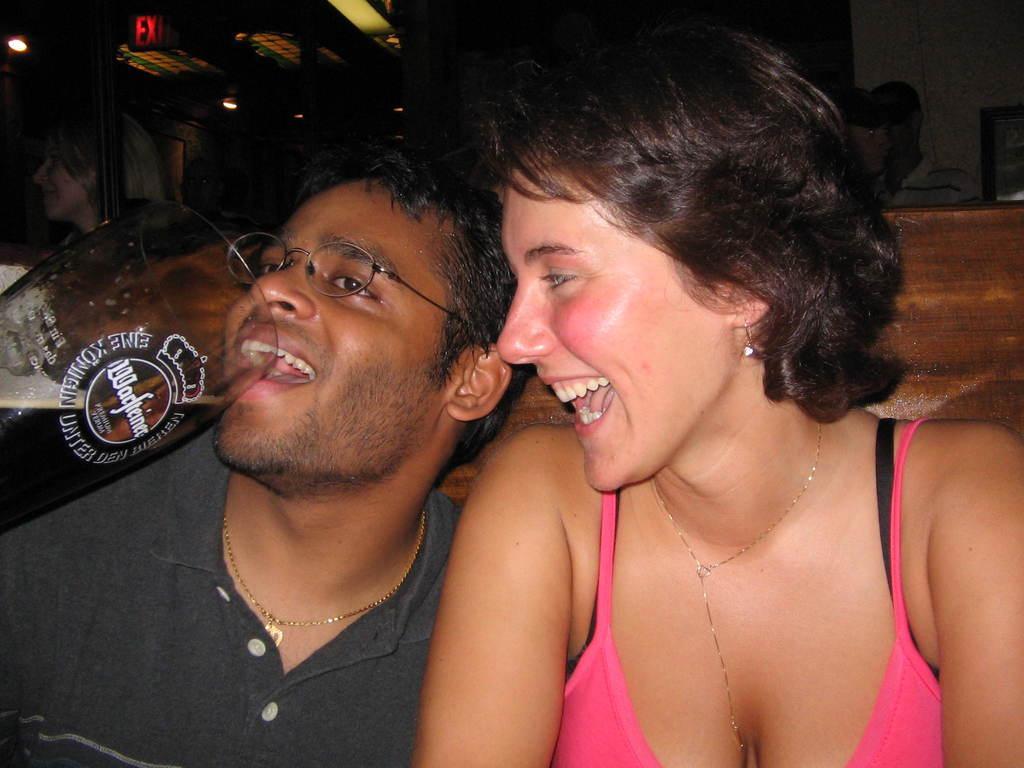Describe this image in one or two sentences. In the image there is a women in pink vest smiling and a man beside her in grey t-shirt having beer and behind them there is wooden wall and few people standing in the background. 